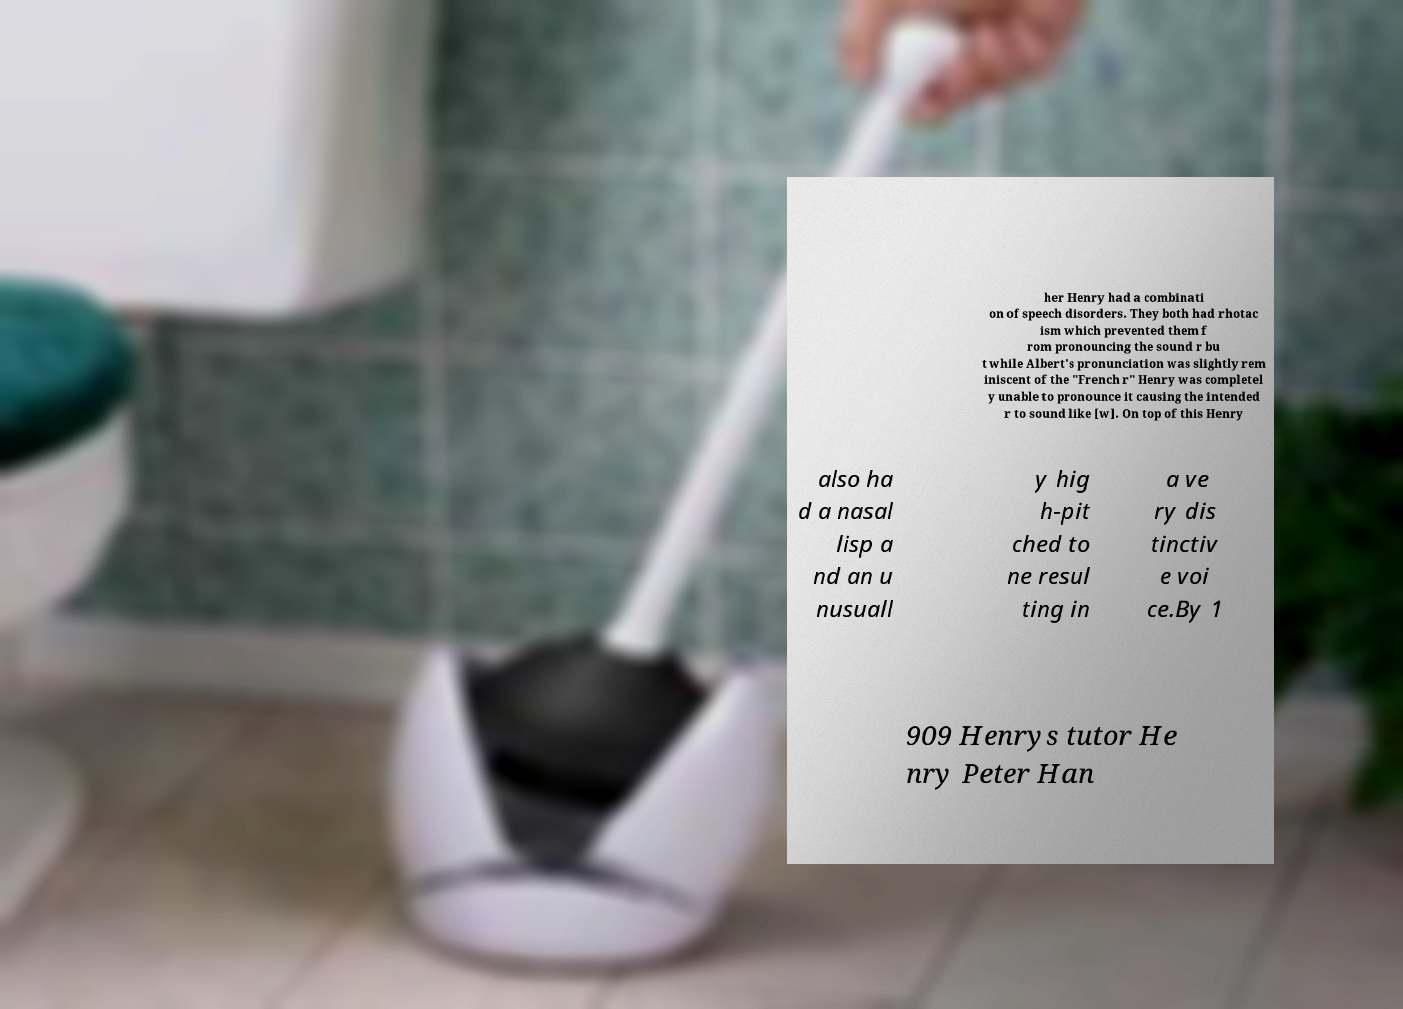Can you read and provide the text displayed in the image?This photo seems to have some interesting text. Can you extract and type it out for me? her Henry had a combinati on of speech disorders. They both had rhotac ism which prevented them f rom pronouncing the sound r bu t while Albert's pronunciation was slightly rem iniscent of the "French r" Henry was completel y unable to pronounce it causing the intended r to sound like [w]. On top of this Henry also ha d a nasal lisp a nd an u nusuall y hig h-pit ched to ne resul ting in a ve ry dis tinctiv e voi ce.By 1 909 Henrys tutor He nry Peter Han 